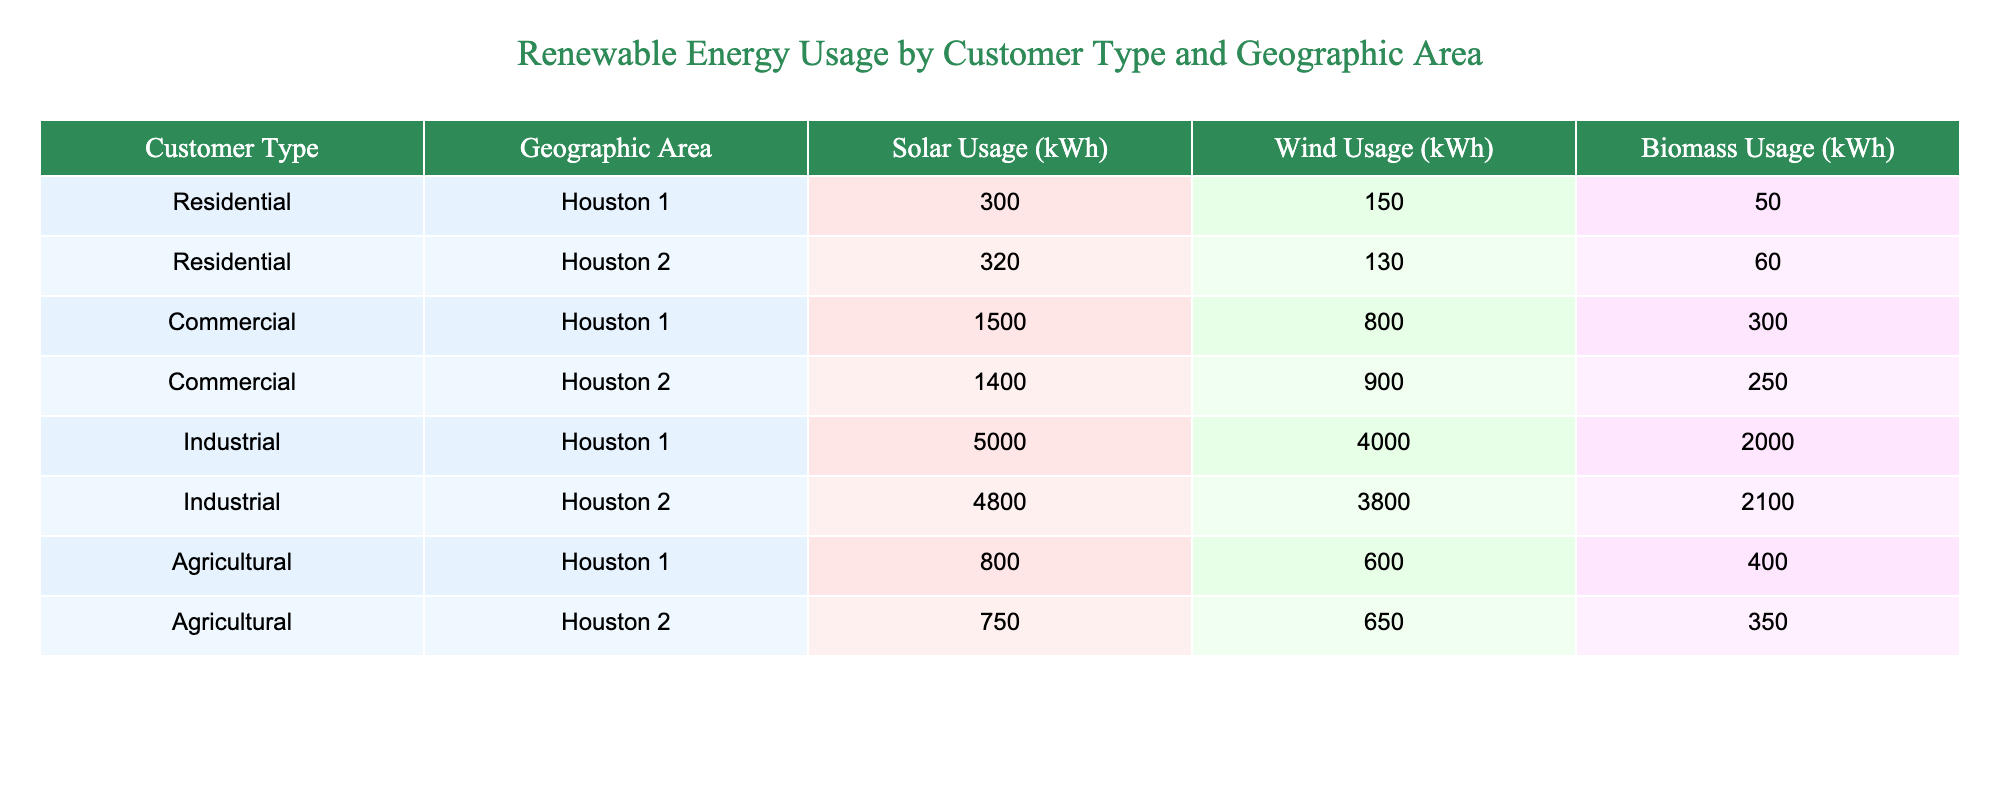What is the total solar usage (kWh) for all Commercial customers? To find the total solar usage for Commercial customers, we look at the two relevant rows: Houston 1 (1500 kWh) and Houston 2 (1400 kWh). Summing these values gives us 1500 + 1400 = 2900 kWh.
Answer: 2900 kWh Which customer type uses the most wind energy in Houston 1? By examining the wind usage for each customer type in Houston 1, we find: Residential (150 kWh), Commercial (800 kWh), Industrial (4000 kWh), and Agricultural (600 kWh). The highest value is 4000 kWh from Industrial customers.
Answer: Industrial Is there any customer type that uses more biomass energy in Houston 2 than in Houston 1? We compare the biomass usage by customer type for Houston 1 and Houston 2: Residential (50 vs. 60), Commercial (300 vs. 250), Industrial (2000 vs. 2100), and Agricultural (400 vs. 350). Residential and Agricultural see increases, while Commercial and Industrial decrease. Thus, yes, Residential and Agricultural use more biomass energy in Houston 2.
Answer: Yes What is the average wind energy usage among all Residential customers? For Residential customers, we have two rows: Houston 1 (150 kWh) and Houston 2 (130 kWh). To find the average, add these values: 150 + 130 = 280 kWh. Then divide by the number of entries (2), yielding an average of 280 / 2 = 140 kWh.
Answer: 140 kWh Which geographic area has the highest total biomass usage overall? To determine which area has the highest total biomass usage, we sum the biomass usage for each area. Houston 1 totals: 50 + 300 + 2000 + 400 = 2750 kWh, and Houston 2 totals: 60 + 250 + 2100 + 350 = 2860 kWh. Houston 2 has the higher total biomass usage.
Answer: Houston 2 